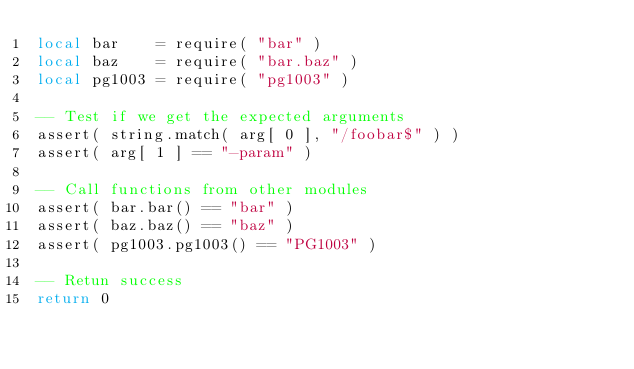<code> <loc_0><loc_0><loc_500><loc_500><_Lua_>local bar    = require( "bar" )
local baz    = require( "bar.baz" )
local pg1003 = require( "pg1003" )

-- Test if we get the expected arguments
assert( string.match( arg[ 0 ], "/foobar$" ) )
assert( arg[ 1 ] == "-param" )

-- Call functions from other modules
assert( bar.bar() == "bar" )
assert( baz.baz() == "baz" )
assert( pg1003.pg1003() == "PG1003" )

-- Retun success
return 0
</code> 